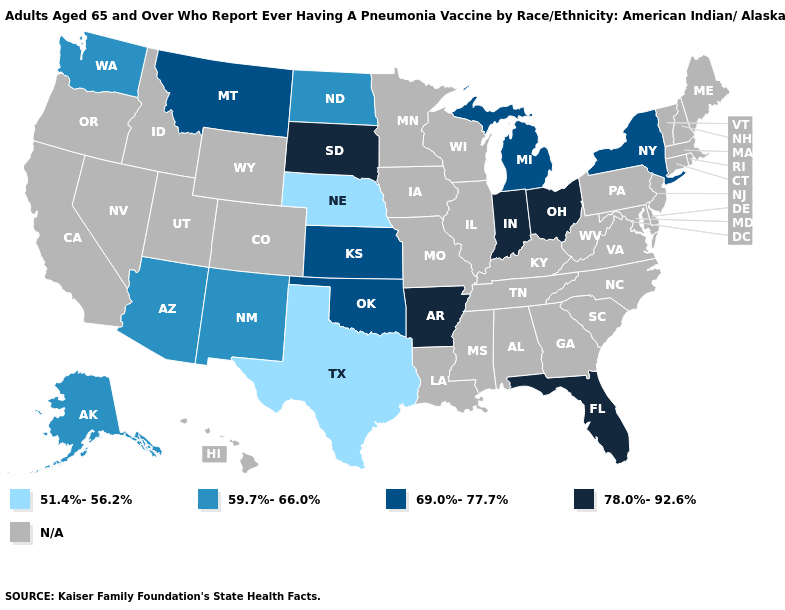Which states have the lowest value in the West?
Keep it brief. Alaska, Arizona, New Mexico, Washington. What is the value of Ohio?
Short answer required. 78.0%-92.6%. Name the states that have a value in the range N/A?
Keep it brief. Alabama, California, Colorado, Connecticut, Delaware, Georgia, Hawaii, Idaho, Illinois, Iowa, Kentucky, Louisiana, Maine, Maryland, Massachusetts, Minnesota, Mississippi, Missouri, Nevada, New Hampshire, New Jersey, North Carolina, Oregon, Pennsylvania, Rhode Island, South Carolina, Tennessee, Utah, Vermont, Virginia, West Virginia, Wisconsin, Wyoming. Among the states that border Missouri , which have the lowest value?
Short answer required. Nebraska. Name the states that have a value in the range 59.7%-66.0%?
Write a very short answer. Alaska, Arizona, New Mexico, North Dakota, Washington. What is the value of Texas?
Be succinct. 51.4%-56.2%. Among the states that border Colorado , does Nebraska have the lowest value?
Be succinct. Yes. What is the lowest value in the USA?
Answer briefly. 51.4%-56.2%. Does Arkansas have the lowest value in the South?
Concise answer only. No. What is the value of Idaho?
Be succinct. N/A. Name the states that have a value in the range 69.0%-77.7%?
Write a very short answer. Kansas, Michigan, Montana, New York, Oklahoma. 